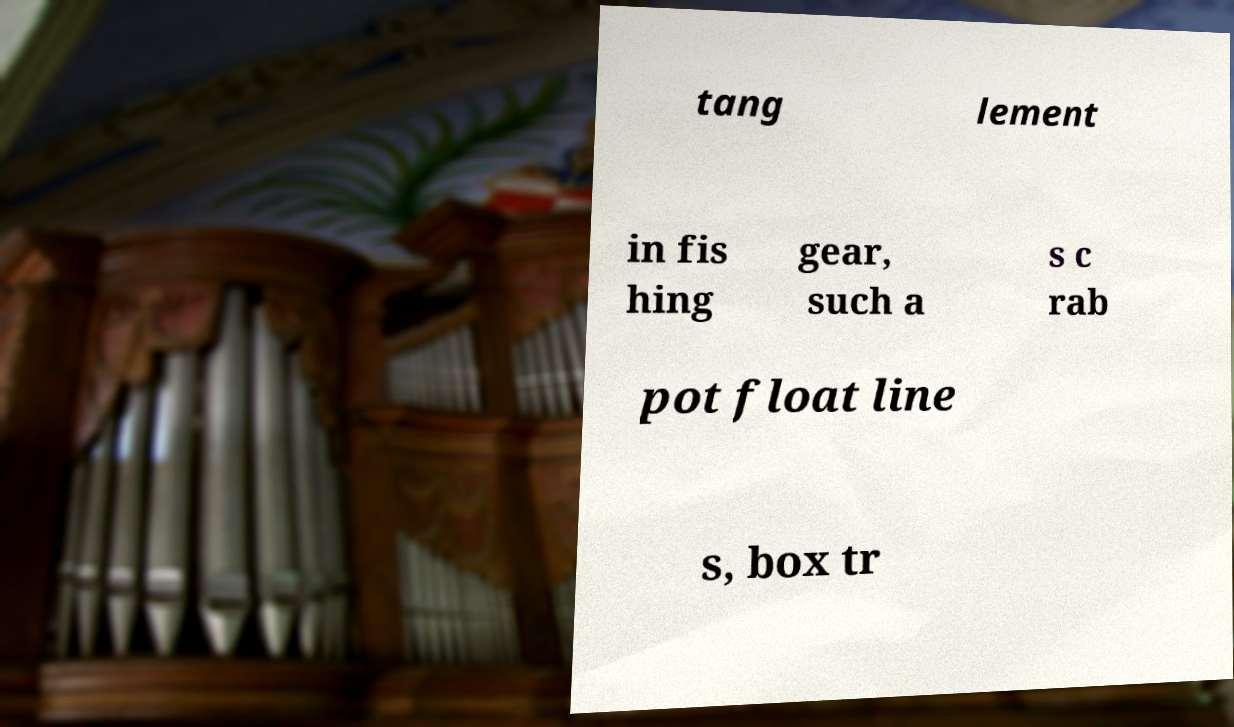Can you accurately transcribe the text from the provided image for me? tang lement in fis hing gear, such a s c rab pot float line s, box tr 